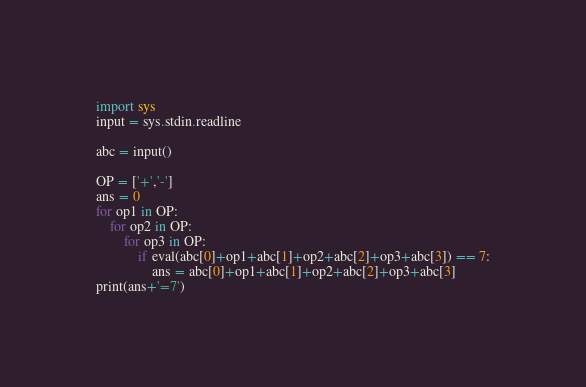Convert code to text. <code><loc_0><loc_0><loc_500><loc_500><_Python_>import sys
input = sys.stdin.readline
 
abc = input()
 
OP = ['+','-']
ans = 0
for op1 in OP:
    for op2 in OP:
        for op3 in OP:
            if eval(abc[0]+op1+abc[1]+op2+abc[2]+op3+abc[3]) == 7:
                ans = abc[0]+op1+abc[1]+op2+abc[2]+op3+abc[3]
print(ans+'=7')</code> 